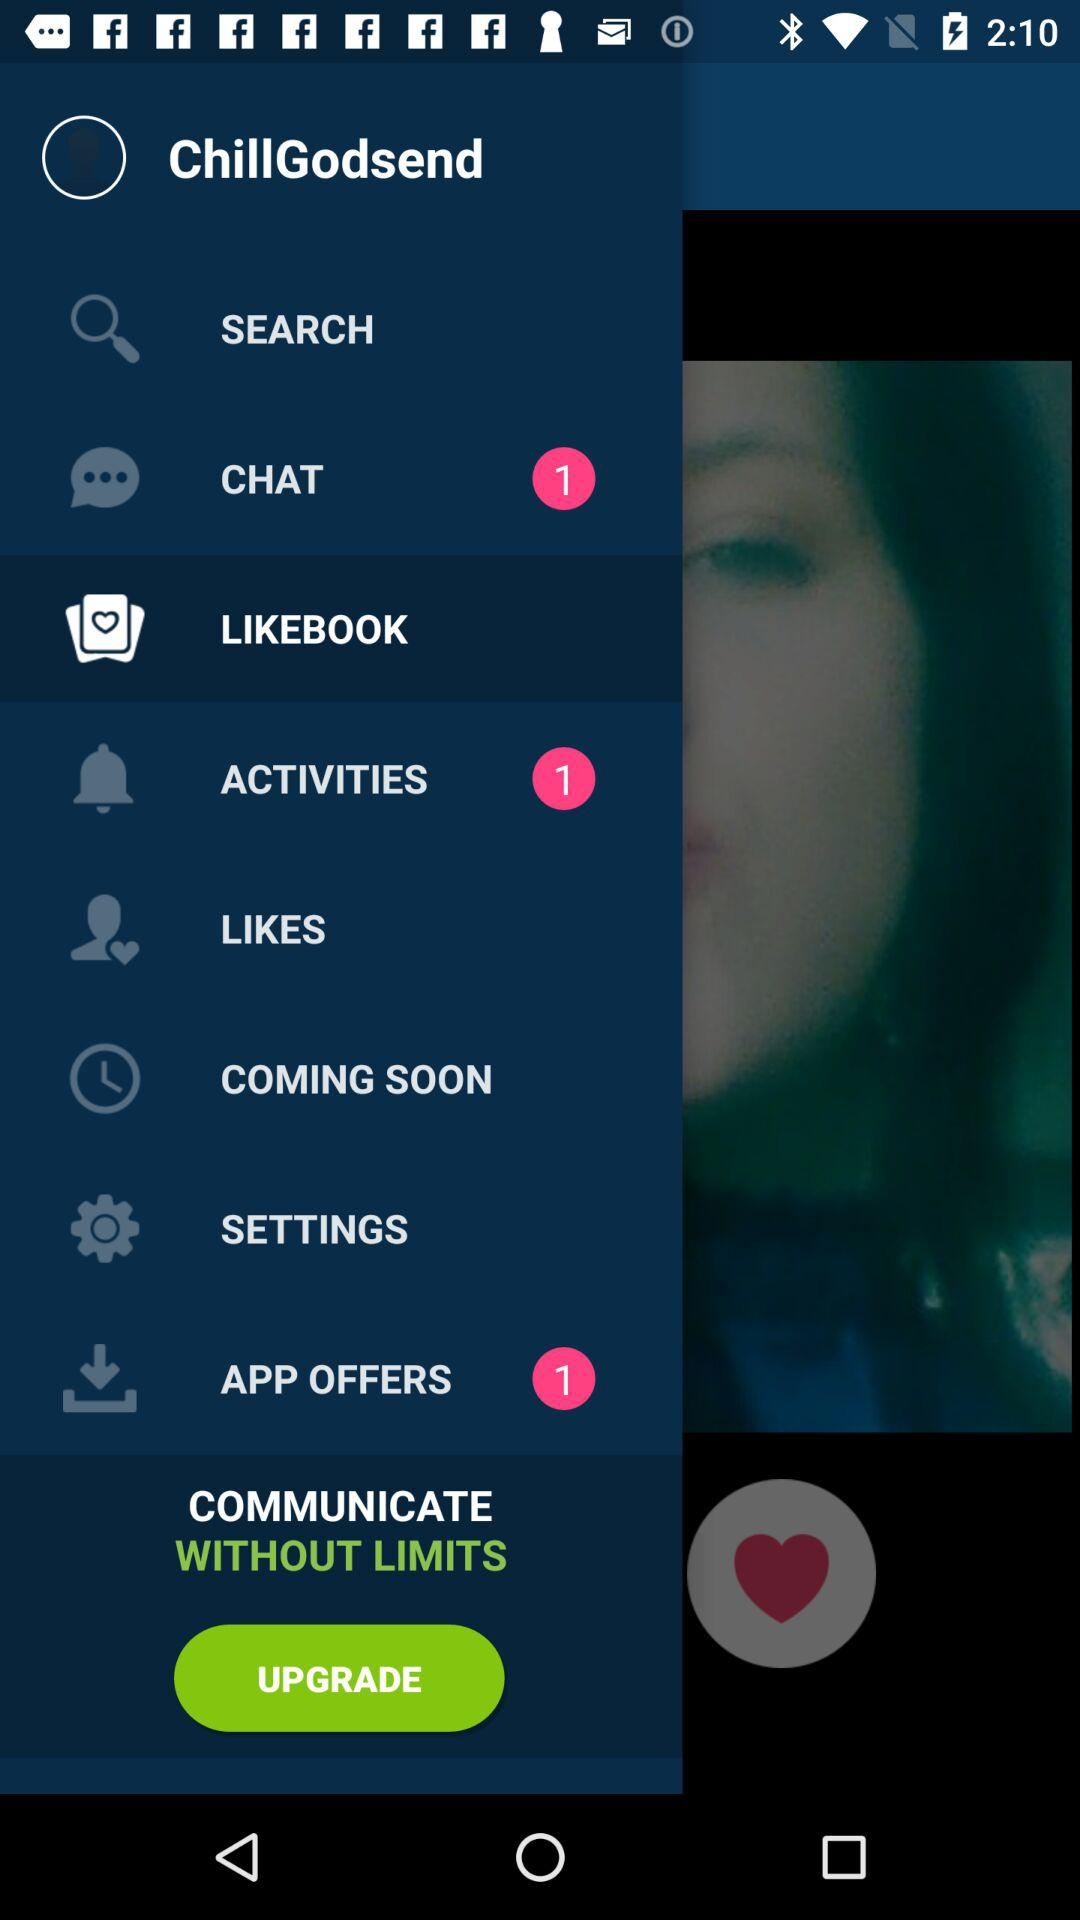Which item is selected? The selected item is "LIKEBOOK". 